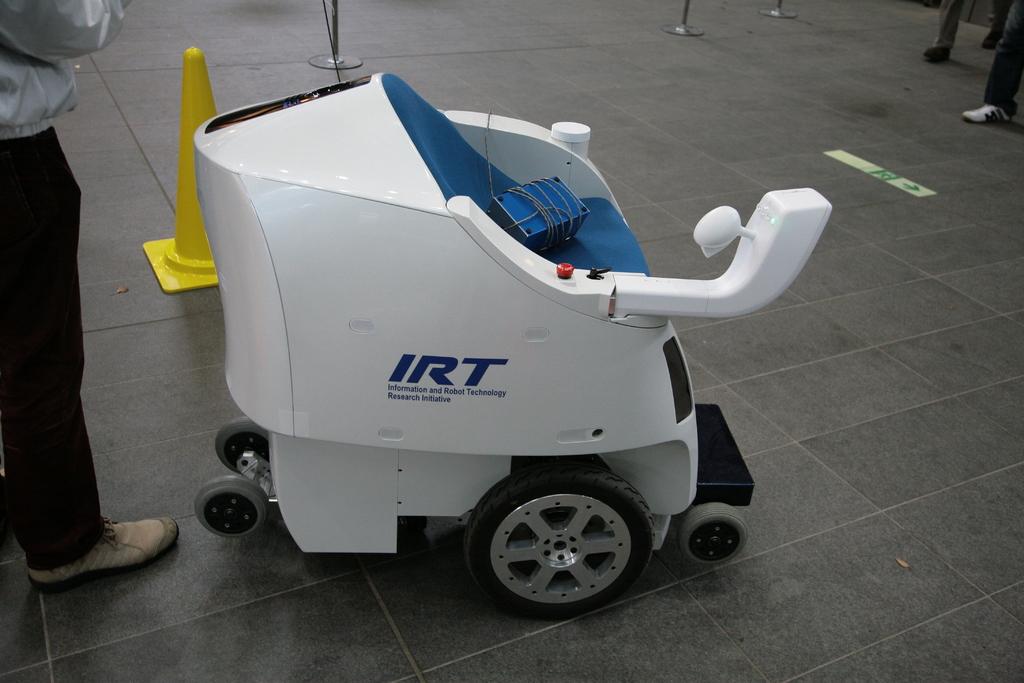What are the initials of the larger text?
Give a very brief answer. Irt. What does irt stand for?
Offer a terse response. Information and robot technology. 